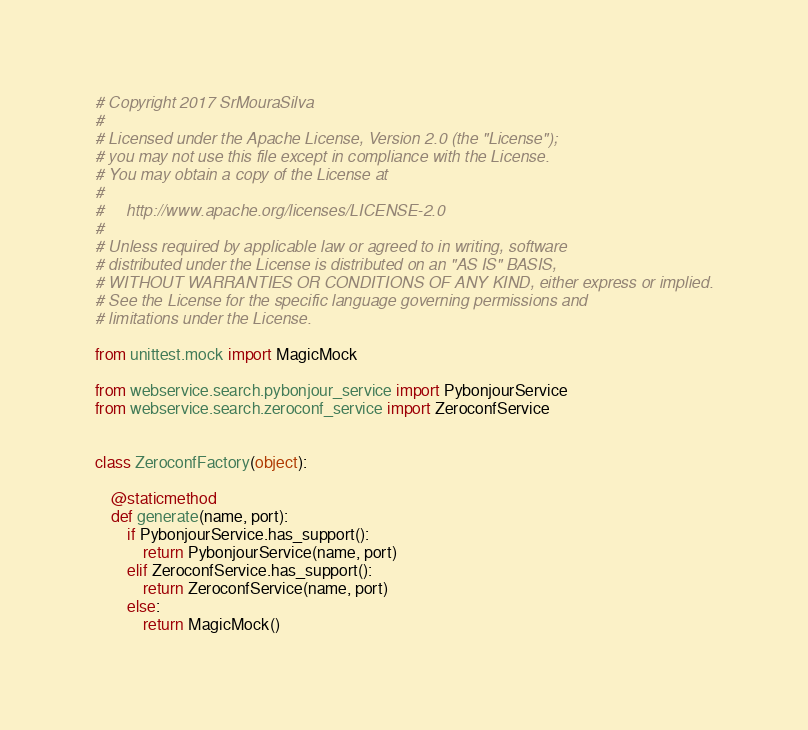Convert code to text. <code><loc_0><loc_0><loc_500><loc_500><_Python_># Copyright 2017 SrMouraSilva
#
# Licensed under the Apache License, Version 2.0 (the "License");
# you may not use this file except in compliance with the License.
# You may obtain a copy of the License at
#
#     http://www.apache.org/licenses/LICENSE-2.0
#
# Unless required by applicable law or agreed to in writing, software
# distributed under the License is distributed on an "AS IS" BASIS,
# WITHOUT WARRANTIES OR CONDITIONS OF ANY KIND, either express or implied.
# See the License for the specific language governing permissions and
# limitations under the License.

from unittest.mock import MagicMock

from webservice.search.pybonjour_service import PybonjourService
from webservice.search.zeroconf_service import ZeroconfService


class ZeroconfFactory(object):

    @staticmethod
    def generate(name, port):
        if PybonjourService.has_support():
            return PybonjourService(name, port)
        elif ZeroconfService.has_support():
            return ZeroconfService(name, port)
        else:
            return MagicMock()
</code> 